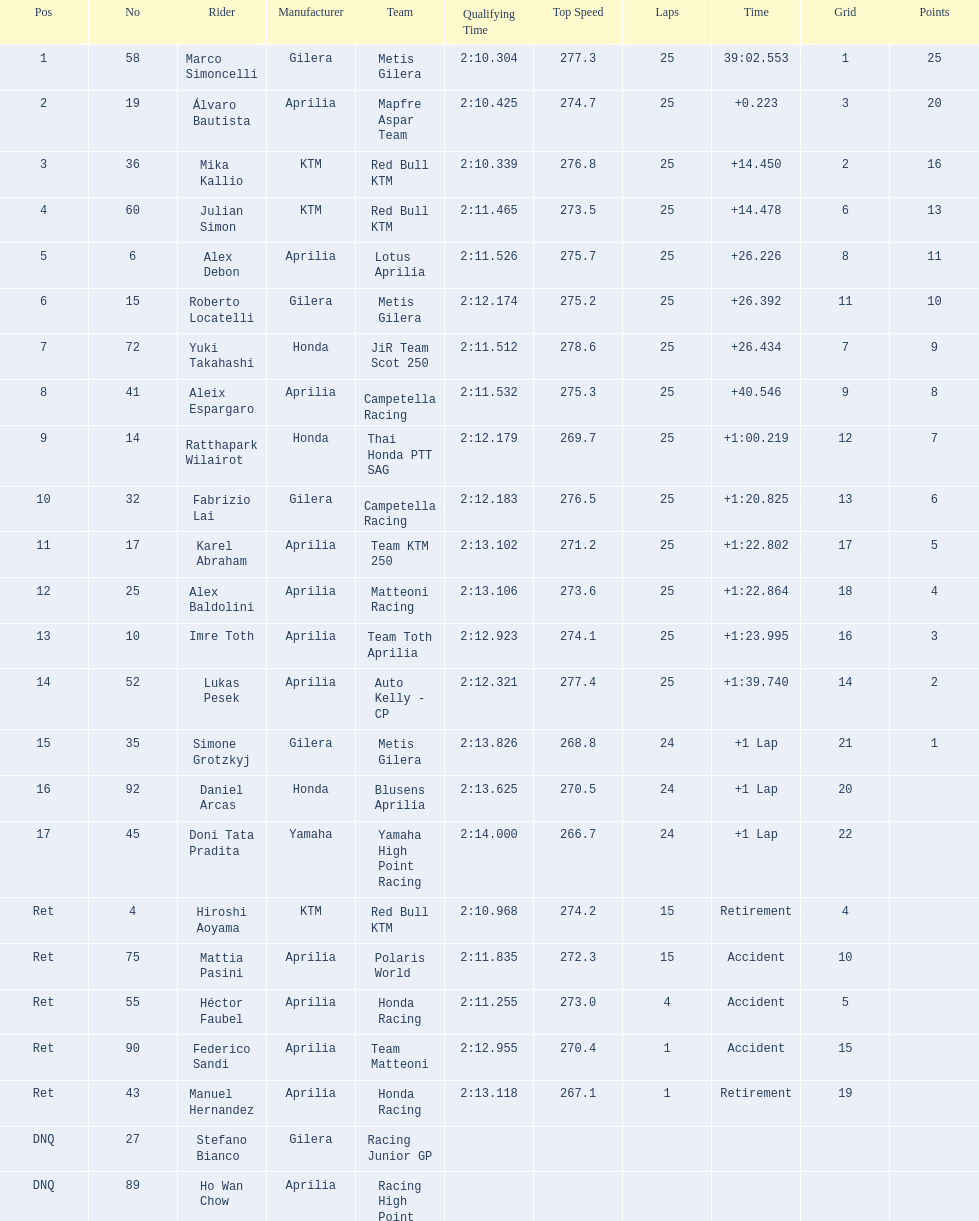How many riders manufacturer is honda? 3. 